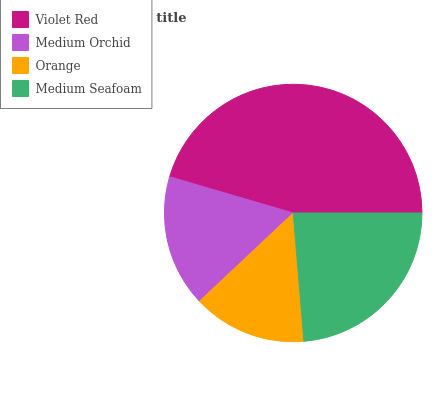Is Orange the minimum?
Answer yes or no. Yes. Is Violet Red the maximum?
Answer yes or no. Yes. Is Medium Orchid the minimum?
Answer yes or no. No. Is Medium Orchid the maximum?
Answer yes or no. No. Is Violet Red greater than Medium Orchid?
Answer yes or no. Yes. Is Medium Orchid less than Violet Red?
Answer yes or no. Yes. Is Medium Orchid greater than Violet Red?
Answer yes or no. No. Is Violet Red less than Medium Orchid?
Answer yes or no. No. Is Medium Seafoam the high median?
Answer yes or no. Yes. Is Medium Orchid the low median?
Answer yes or no. Yes. Is Orange the high median?
Answer yes or no. No. Is Orange the low median?
Answer yes or no. No. 